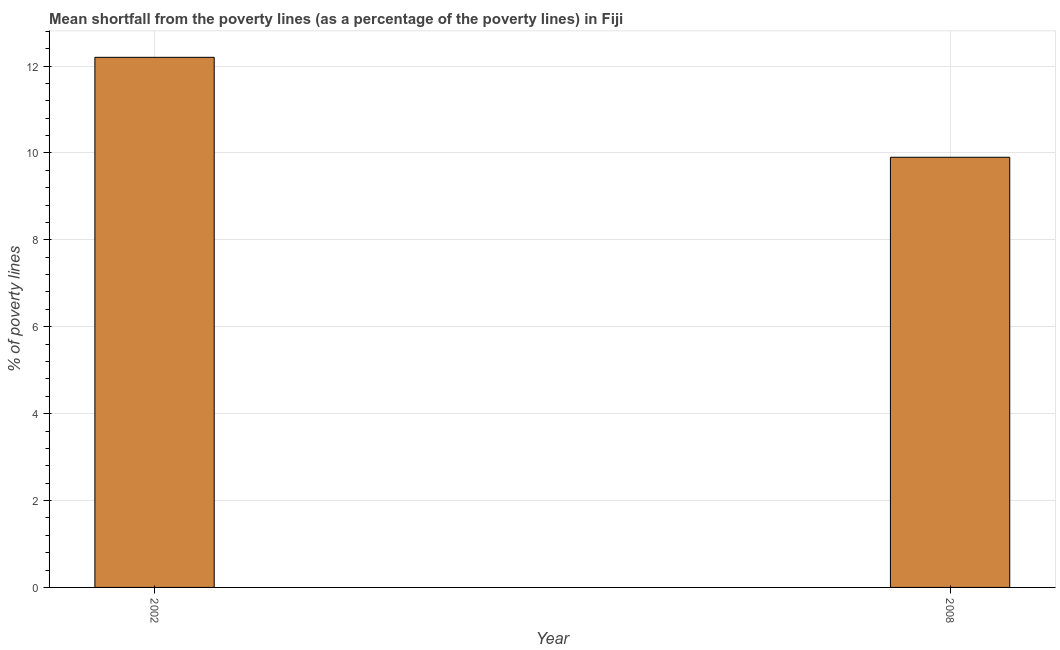Does the graph contain any zero values?
Give a very brief answer. No. What is the title of the graph?
Your answer should be compact. Mean shortfall from the poverty lines (as a percentage of the poverty lines) in Fiji. What is the label or title of the Y-axis?
Your answer should be compact. % of poverty lines. What is the poverty gap at national poverty lines in 2008?
Your answer should be compact. 9.9. Across all years, what is the maximum poverty gap at national poverty lines?
Offer a terse response. 12.2. Across all years, what is the minimum poverty gap at national poverty lines?
Offer a very short reply. 9.9. In which year was the poverty gap at national poverty lines minimum?
Give a very brief answer. 2008. What is the sum of the poverty gap at national poverty lines?
Keep it short and to the point. 22.1. What is the average poverty gap at national poverty lines per year?
Give a very brief answer. 11.05. What is the median poverty gap at national poverty lines?
Offer a terse response. 11.05. In how many years, is the poverty gap at national poverty lines greater than 2 %?
Your answer should be compact. 2. What is the ratio of the poverty gap at national poverty lines in 2002 to that in 2008?
Provide a short and direct response. 1.23. Is the poverty gap at national poverty lines in 2002 less than that in 2008?
Your answer should be compact. No. How many bars are there?
Make the answer very short. 2. Are all the bars in the graph horizontal?
Keep it short and to the point. No. What is the % of poverty lines of 2002?
Keep it short and to the point. 12.2. What is the % of poverty lines in 2008?
Give a very brief answer. 9.9. What is the difference between the % of poverty lines in 2002 and 2008?
Make the answer very short. 2.3. What is the ratio of the % of poverty lines in 2002 to that in 2008?
Your response must be concise. 1.23. 